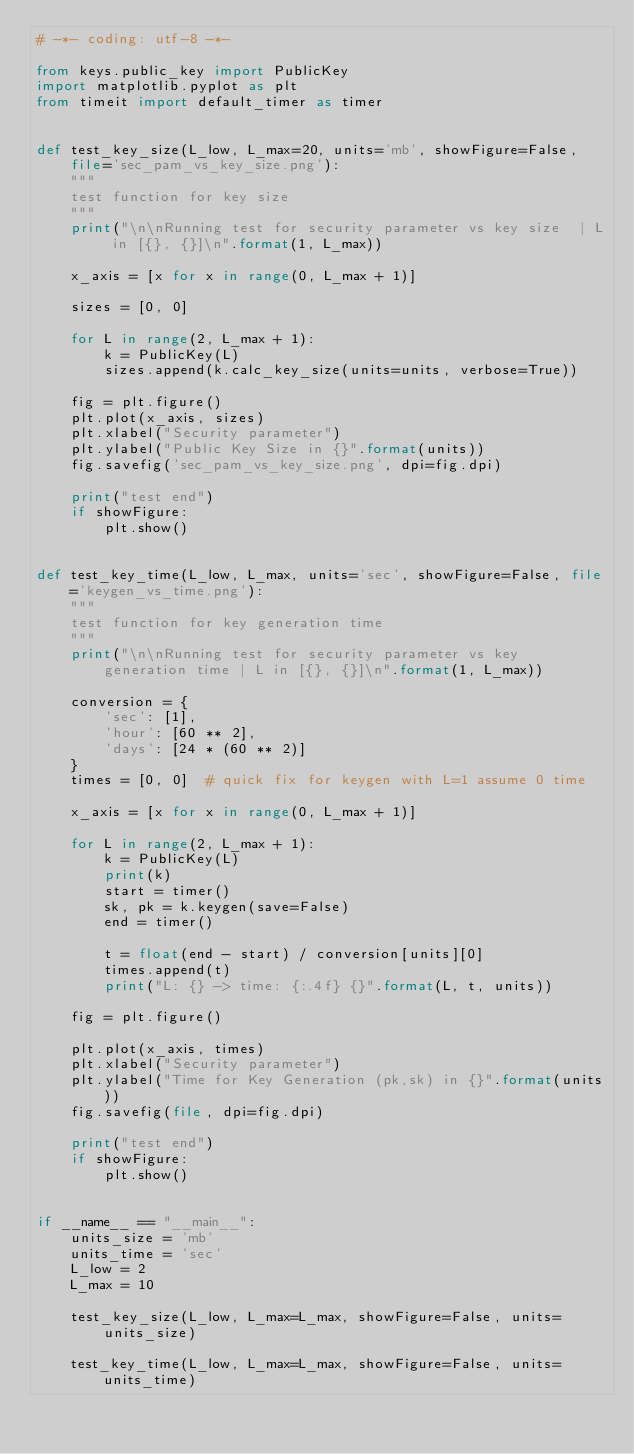<code> <loc_0><loc_0><loc_500><loc_500><_Python_># -*- coding: utf-8 -*-

from keys.public_key import PublicKey
import matplotlib.pyplot as plt
from timeit import default_timer as timer


def test_key_size(L_low, L_max=20, units='mb', showFigure=False, file='sec_pam_vs_key_size.png'):
    """
    test function for key size
    """
    print("\n\nRunning test for security parameter vs key size  | L in [{}, {}]\n".format(1, L_max))

    x_axis = [x for x in range(0, L_max + 1)]

    sizes = [0, 0]

    for L in range(2, L_max + 1):
        k = PublicKey(L)
        sizes.append(k.calc_key_size(units=units, verbose=True))

    fig = plt.figure()
    plt.plot(x_axis, sizes)
    plt.xlabel("Security parameter")
    plt.ylabel("Public Key Size in {}".format(units))
    fig.savefig('sec_pam_vs_key_size.png', dpi=fig.dpi)

    print("test end")
    if showFigure:
        plt.show()


def test_key_time(L_low, L_max, units='sec', showFigure=False, file='keygen_vs_time.png'):
    """
    test function for key generation time
    """
    print("\n\nRunning test for security parameter vs key generation time | L in [{}, {}]\n".format(1, L_max))

    conversion = {
        'sec': [1],
        'hour': [60 ** 2],
        'days': [24 * (60 ** 2)]
    }
    times = [0, 0]  # quick fix for keygen with L=1 assume 0 time

    x_axis = [x for x in range(0, L_max + 1)]

    for L in range(2, L_max + 1):
        k = PublicKey(L)
        print(k)
        start = timer()
        sk, pk = k.keygen(save=False)
        end = timer()

        t = float(end - start) / conversion[units][0]
        times.append(t)
        print("L: {} -> time: {:.4f} {}".format(L, t, units))

    fig = plt.figure()

    plt.plot(x_axis, times)
    plt.xlabel("Security parameter")
    plt.ylabel("Time for Key Generation (pk,sk) in {}".format(units))
    fig.savefig(file, dpi=fig.dpi)

    print("test end")
    if showFigure:
        plt.show()


if __name__ == "__main__":
    units_size = 'mb'
    units_time = 'sec'
    L_low = 2
    L_max = 10

    test_key_size(L_low, L_max=L_max, showFigure=False, units=units_size)

    test_key_time(L_low, L_max=L_max, showFigure=False, units=units_time)
</code> 